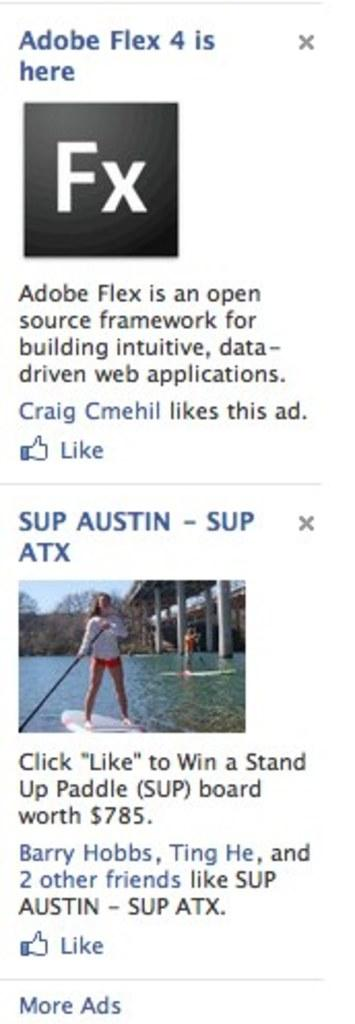What is featured in the image along with the woman boating in the water? There is a logo and text in the image. What can be seen in the background of the image? There are poles, trees, and the sky visible in the background of the image. What time of day was the image taken? The image was taken during the day. What type of pleasure does the woman experience while boating in the image? The image does not provide information about the woman's emotions or experiences while boating. What is the woman's opinion about the tub in the image? There is no tub present in the image. 